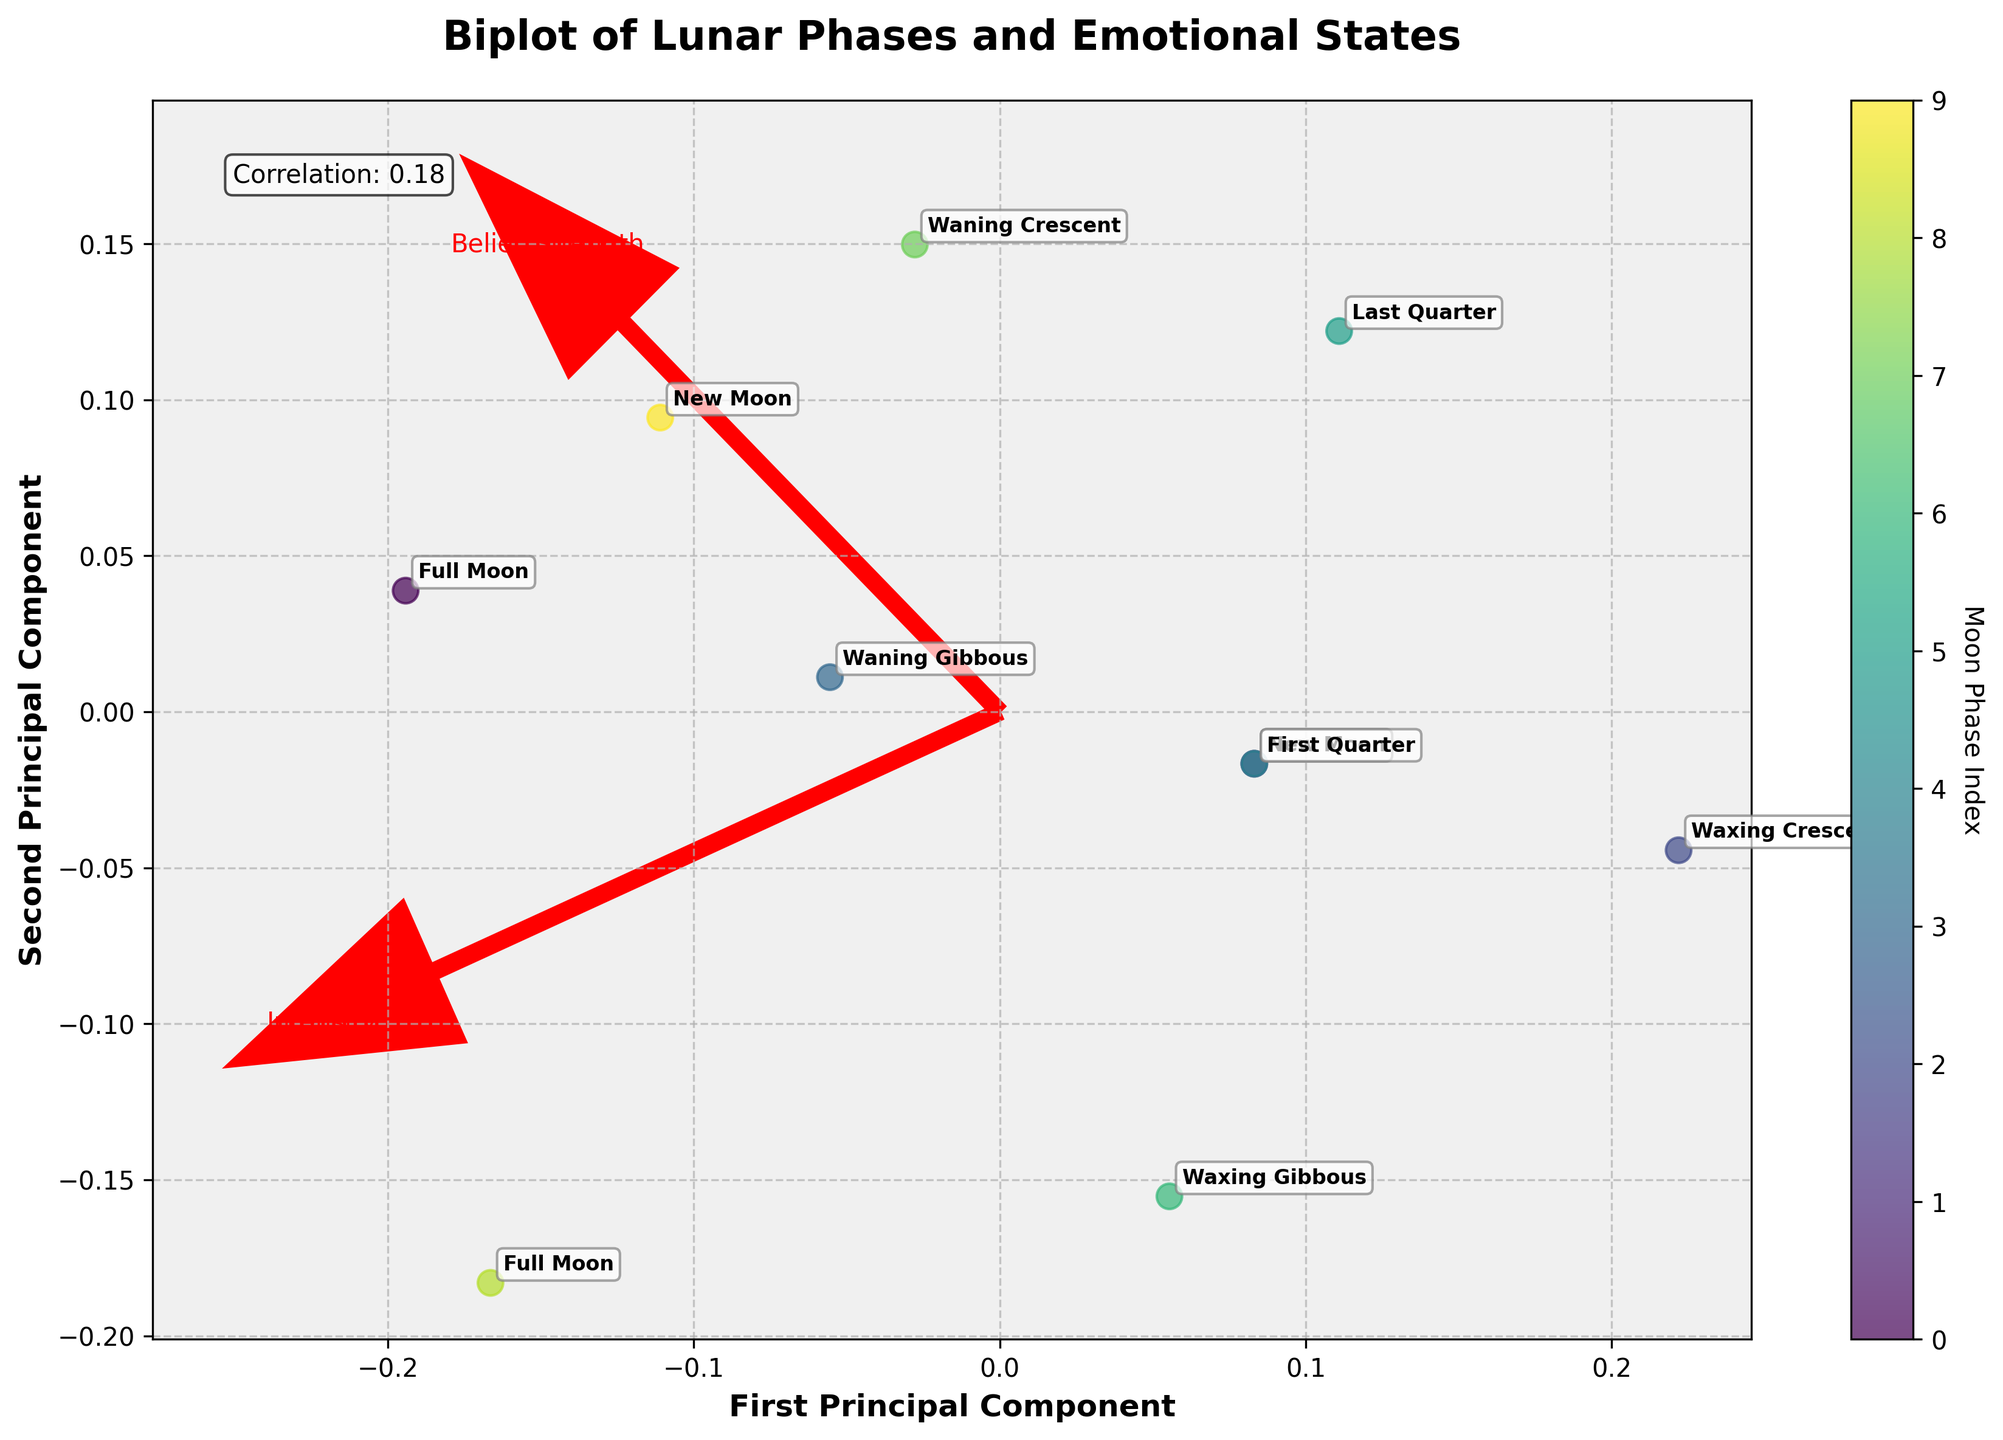what is the title of the plot? The title is always at the top of the figure, usually with larger and bold fonts. Here, it reads "Biplot of Lunar Phases and Emotional States."
Answer: Biplot of Lunar Phases and Emotional States what is represented on the X-axis? The label on the X-axis indicates what is measured on that axis. Here, it says "First Principal Component."
Answer: First Principal Component how many different moon phases are depicted in the plot? The number of unique labels annotated on the plot represents the different moon phases. By counting them, we find there are 10 unique annotations.
Answer: 10 which moon phase corresponds to the highest intensity? By locating the point with the highest value on the feature vector for "Intensity" (X-axis) and checking the corresponding annotation, we find that the "Full Moon" (Brazilian) has the highest intensity.
Answer: Full Moon (Brazilian) what is the correlation coefficient between Intensity and Belief Strength? The correlation coefficient is directly displayed on the plot, usually in the corner or within some text box. Here, it is noted as "Correlation: 0.79."
Answer: 0.79 how do the vectors "Intensity" and "Belief Strength" relate to the data points? The vectors point in the direction of the maximum variance for each feature. If data points are projected close to the vector’s direction, they have higher values for that feature.
Answer: Points near vector direction have higher values which data points are closest to the vector "Belief Strength"? By observing which data points or moon phases are aligned more closely with the "Belief Strength" vector direction, we see that "Waning Crescent" (Egyptian) and "Full Moon" (Japanese) are closest.
Answer: Waning Crescent (Egyptian) and Full Moon (Japanese) are any moon phases clustered together in the plot? By visually examining the plot for groups of annotations that are close to each other, we determine if there are any noticeable clusters. Here, "Waning Gibbous" (Mayan) and "Waxing Gibbous" (Nordic) appear close.
Answer: Waning Gibbous (Mayan) and Waxing Gibbous (Nordic) which moon phase shows the lowest belief strength? By finding the point that is furthest along the negative direction of the "Belief Strength" vector (Y-axis), we identify the annotation "Waxing Crescent" (Greek) as the phase with the lowest belief strength.
Answer: Waxing Crescent (Greek) what is the main insight provided by the Biplot? The Biplot shows how different moon phases relate to emotional states by their intensities and belief strengths, indicating that certain phases like "Full Moon" are associated with stronger emotions and beliefs.
Answer: Full Moon associated with stronger emotions and beliefs 